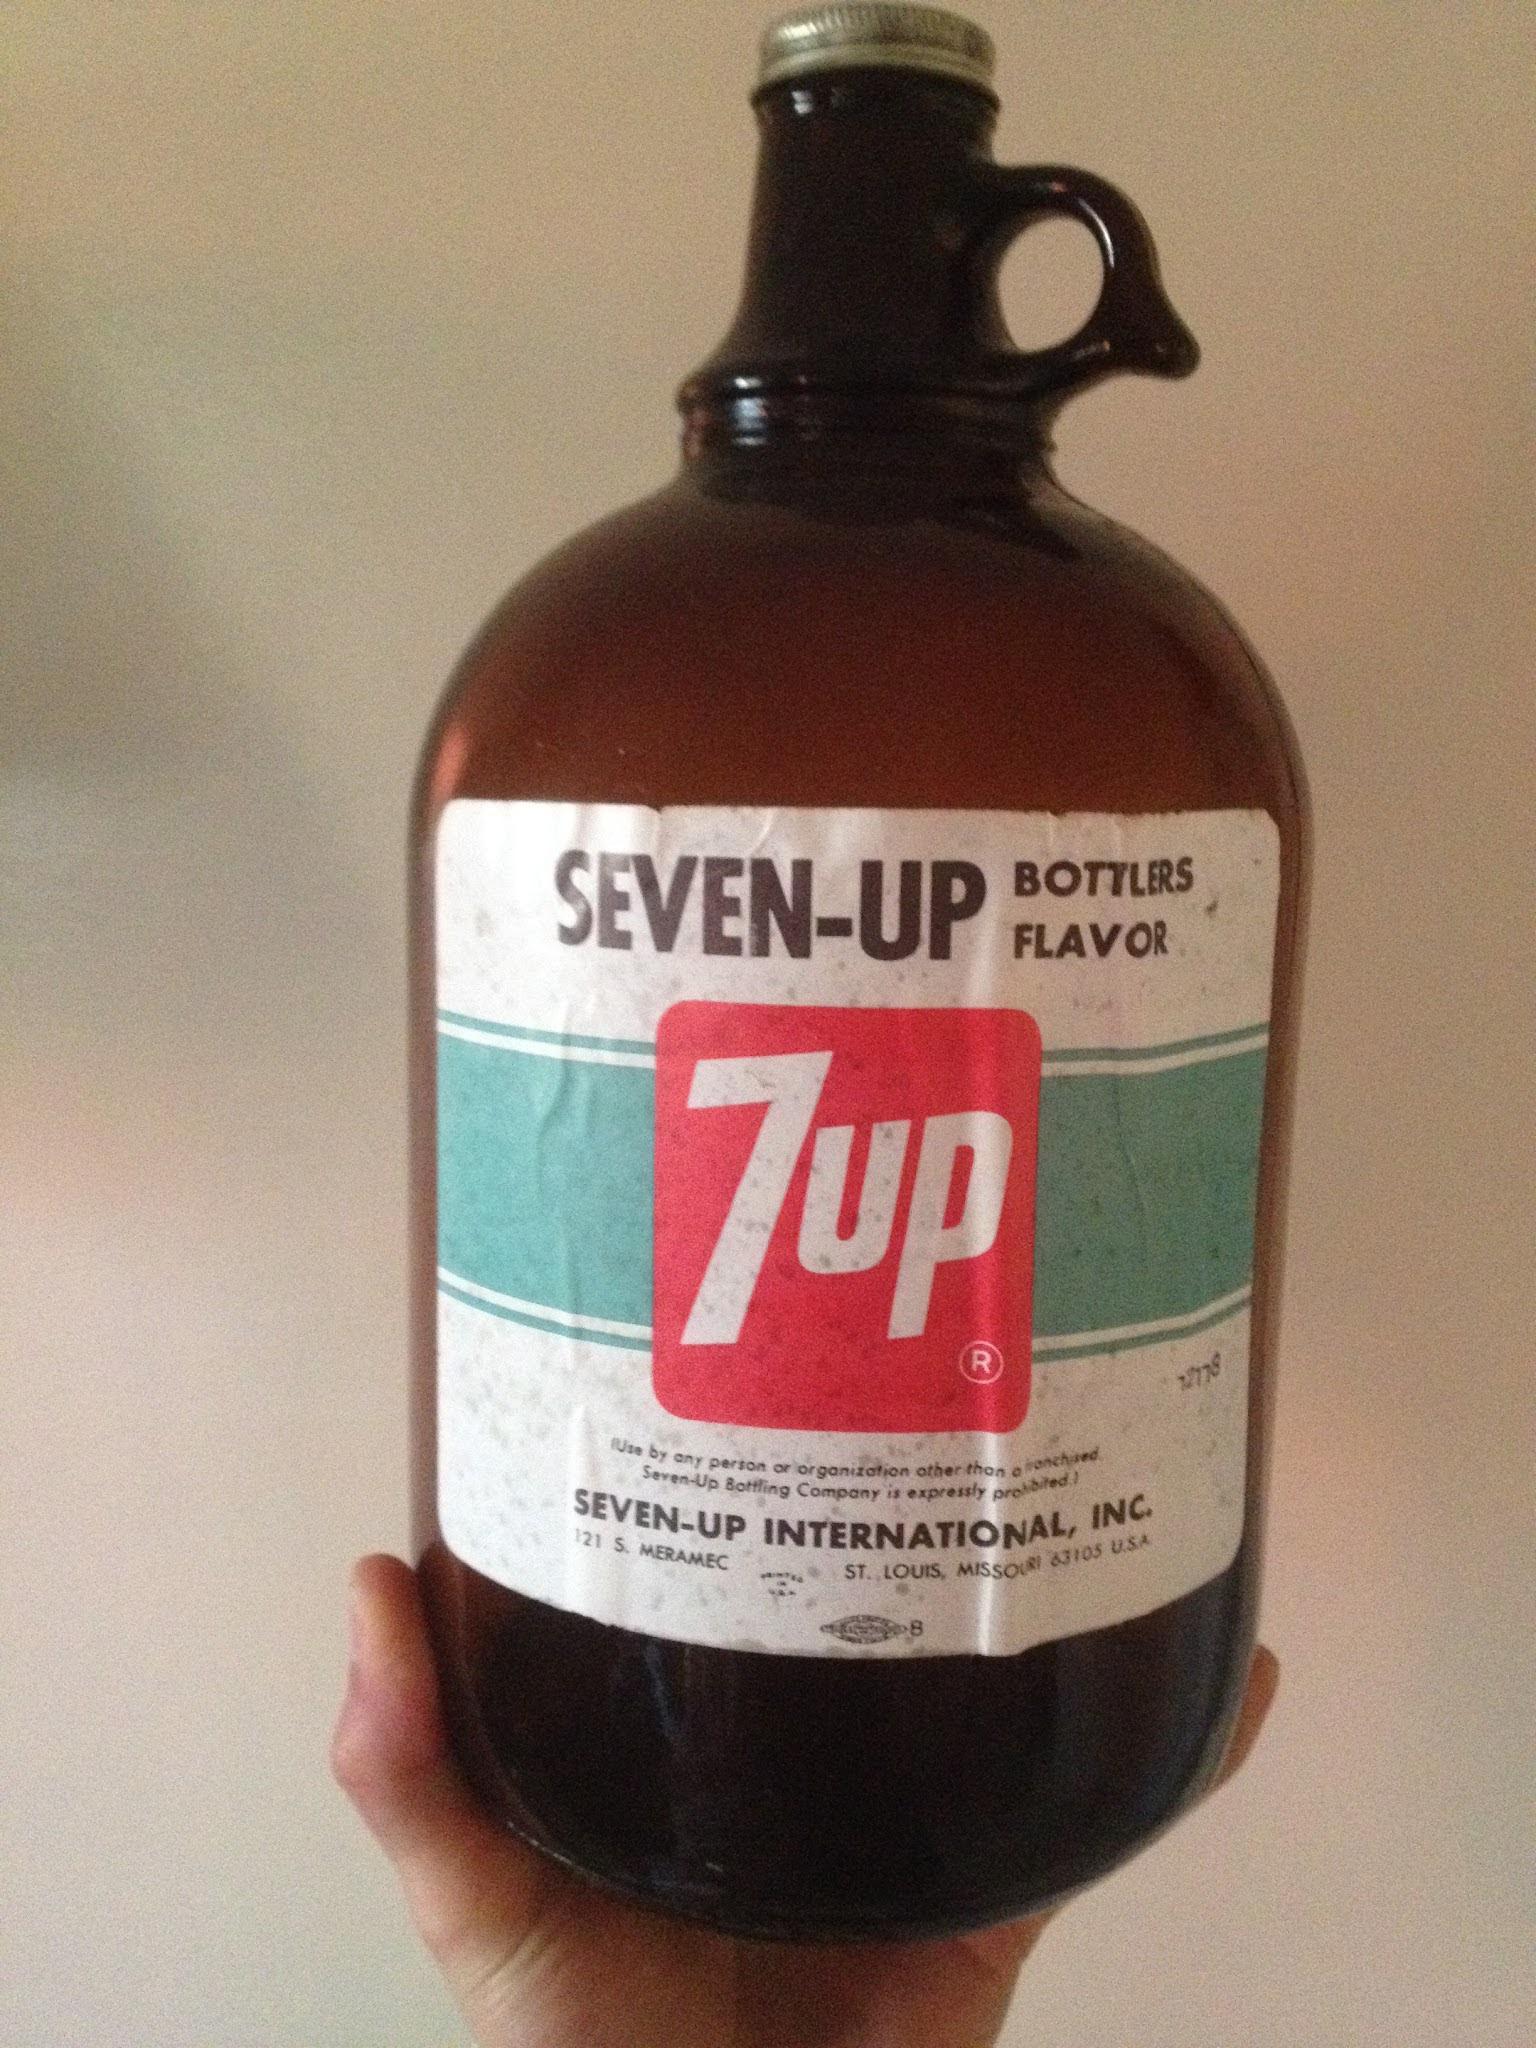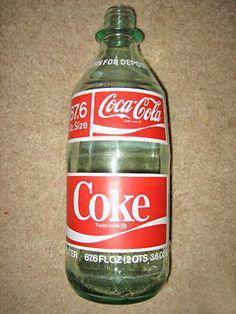The first image is the image on the left, the second image is the image on the right. Given the left and right images, does the statement "There is one bottle in each image." hold true? Answer yes or no. Yes. The first image is the image on the left, the second image is the image on the right. Assess this claim about the two images: "The bottle in one of the images could be called a jug.". Correct or not? Answer yes or no. Yes. 